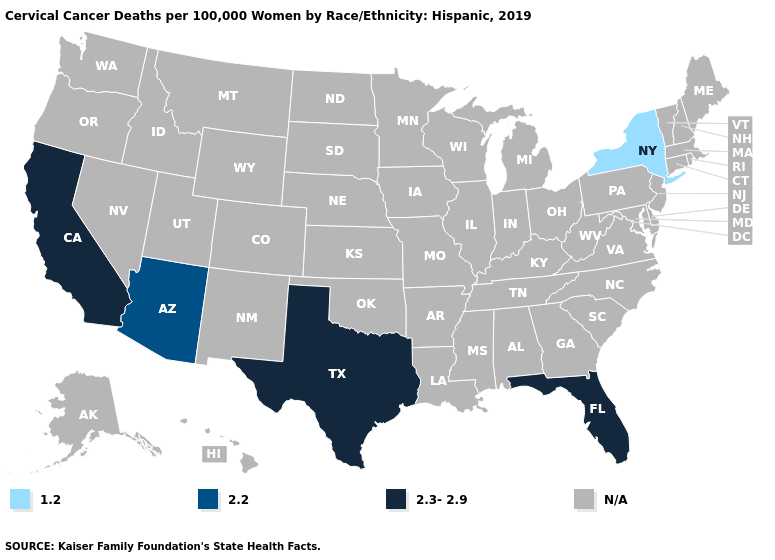What is the value of Alabama?
Write a very short answer. N/A. What is the value of Arizona?
Quick response, please. 2.2. Name the states that have a value in the range 1.2?
Keep it brief. New York. What is the lowest value in states that border Utah?
Concise answer only. 2.2. Does the first symbol in the legend represent the smallest category?
Keep it brief. Yes. What is the value of Vermont?
Be succinct. N/A. Name the states that have a value in the range N/A?
Quick response, please. Alabama, Alaska, Arkansas, Colorado, Connecticut, Delaware, Georgia, Hawaii, Idaho, Illinois, Indiana, Iowa, Kansas, Kentucky, Louisiana, Maine, Maryland, Massachusetts, Michigan, Minnesota, Mississippi, Missouri, Montana, Nebraska, Nevada, New Hampshire, New Jersey, New Mexico, North Carolina, North Dakota, Ohio, Oklahoma, Oregon, Pennsylvania, Rhode Island, South Carolina, South Dakota, Tennessee, Utah, Vermont, Virginia, Washington, West Virginia, Wisconsin, Wyoming. How many symbols are there in the legend?
Give a very brief answer. 4. Does Arizona have the highest value in the USA?
Short answer required. No. Does California have the lowest value in the USA?
Concise answer only. No. Which states have the lowest value in the Northeast?
Keep it brief. New York. 